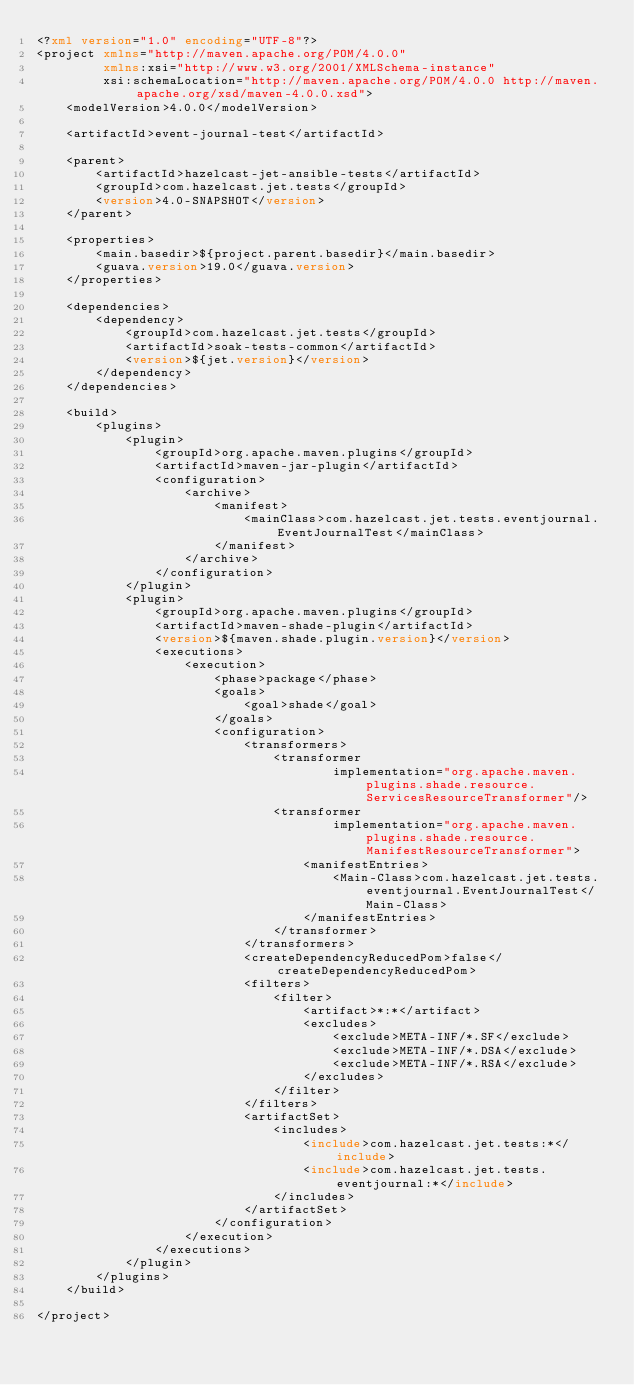Convert code to text. <code><loc_0><loc_0><loc_500><loc_500><_XML_><?xml version="1.0" encoding="UTF-8"?>
<project xmlns="http://maven.apache.org/POM/4.0.0"
         xmlns:xsi="http://www.w3.org/2001/XMLSchema-instance"
         xsi:schemaLocation="http://maven.apache.org/POM/4.0.0 http://maven.apache.org/xsd/maven-4.0.0.xsd">
    <modelVersion>4.0.0</modelVersion>

    <artifactId>event-journal-test</artifactId>

    <parent>
        <artifactId>hazelcast-jet-ansible-tests</artifactId>
        <groupId>com.hazelcast.jet.tests</groupId>
        <version>4.0-SNAPSHOT</version>
    </parent>

    <properties>
        <main.basedir>${project.parent.basedir}</main.basedir>
        <guava.version>19.0</guava.version>
    </properties>

    <dependencies>
        <dependency>
            <groupId>com.hazelcast.jet.tests</groupId>
            <artifactId>soak-tests-common</artifactId>
            <version>${jet.version}</version>
        </dependency>
    </dependencies>

    <build>
        <plugins>
            <plugin>
                <groupId>org.apache.maven.plugins</groupId>
                <artifactId>maven-jar-plugin</artifactId>
                <configuration>
                    <archive>
                        <manifest>
                            <mainClass>com.hazelcast.jet.tests.eventjournal.EventJournalTest</mainClass>
                        </manifest>
                    </archive>
                </configuration>
            </plugin>
            <plugin>
                <groupId>org.apache.maven.plugins</groupId>
                <artifactId>maven-shade-plugin</artifactId>
                <version>${maven.shade.plugin.version}</version>
                <executions>
                    <execution>
                        <phase>package</phase>
                        <goals>
                            <goal>shade</goal>
                        </goals>
                        <configuration>
                            <transformers>
                                <transformer
                                        implementation="org.apache.maven.plugins.shade.resource.ServicesResourceTransformer"/>
                                <transformer
                                        implementation="org.apache.maven.plugins.shade.resource.ManifestResourceTransformer">
                                    <manifestEntries>
                                        <Main-Class>com.hazelcast.jet.tests.eventjournal.EventJournalTest</Main-Class>
                                    </manifestEntries>
                                </transformer>
                            </transformers>
                            <createDependencyReducedPom>false</createDependencyReducedPom>
                            <filters>
                                <filter>
                                    <artifact>*:*</artifact>
                                    <excludes>
                                        <exclude>META-INF/*.SF</exclude>
                                        <exclude>META-INF/*.DSA</exclude>
                                        <exclude>META-INF/*.RSA</exclude>
                                    </excludes>
                                </filter>
                            </filters>
                            <artifactSet>
                                <includes>
                                    <include>com.hazelcast.jet.tests:*</include>
                                    <include>com.hazelcast.jet.tests.eventjournal:*</include>
                                </includes>
                            </artifactSet>
                        </configuration>
                    </execution>
                </executions>
            </plugin>
        </plugins>
    </build>

</project></code> 